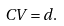Convert formula to latex. <formula><loc_0><loc_0><loc_500><loc_500>C V = d .</formula> 